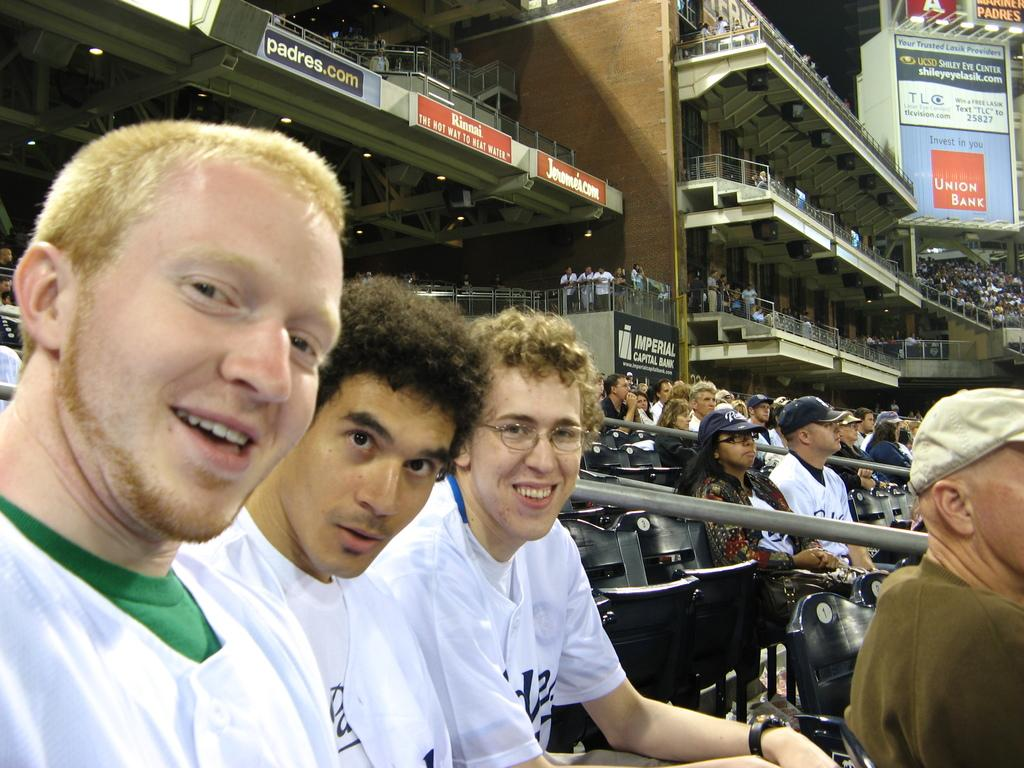How many people are in the image? There are people in the image, but the exact number is not specified. What are some of the men in the image wearing? Some men in the image are wearing t-shirts. What can be seen in the background of the image? In the background of the image, there are boards, a fence, chairs, and other objects. Can you describe the setting of the image? The image appears to be set outdoors, with a fence and other objects in the background. How many wings can be seen on the roof in the image? There is no roof or wings present in the image. What type of self-driving car is visible in the image? There is no car, self-driving or otherwise, present in the image. 